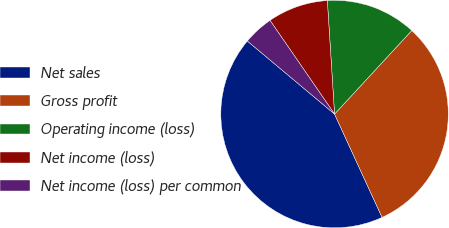Convert chart to OTSL. <chart><loc_0><loc_0><loc_500><loc_500><pie_chart><fcel>Net sales<fcel>Gross profit<fcel>Operating income (loss)<fcel>Net income (loss)<fcel>Net income (loss) per common<nl><fcel>42.96%<fcel>31.26%<fcel>12.89%<fcel>8.59%<fcel>4.3%<nl></chart> 